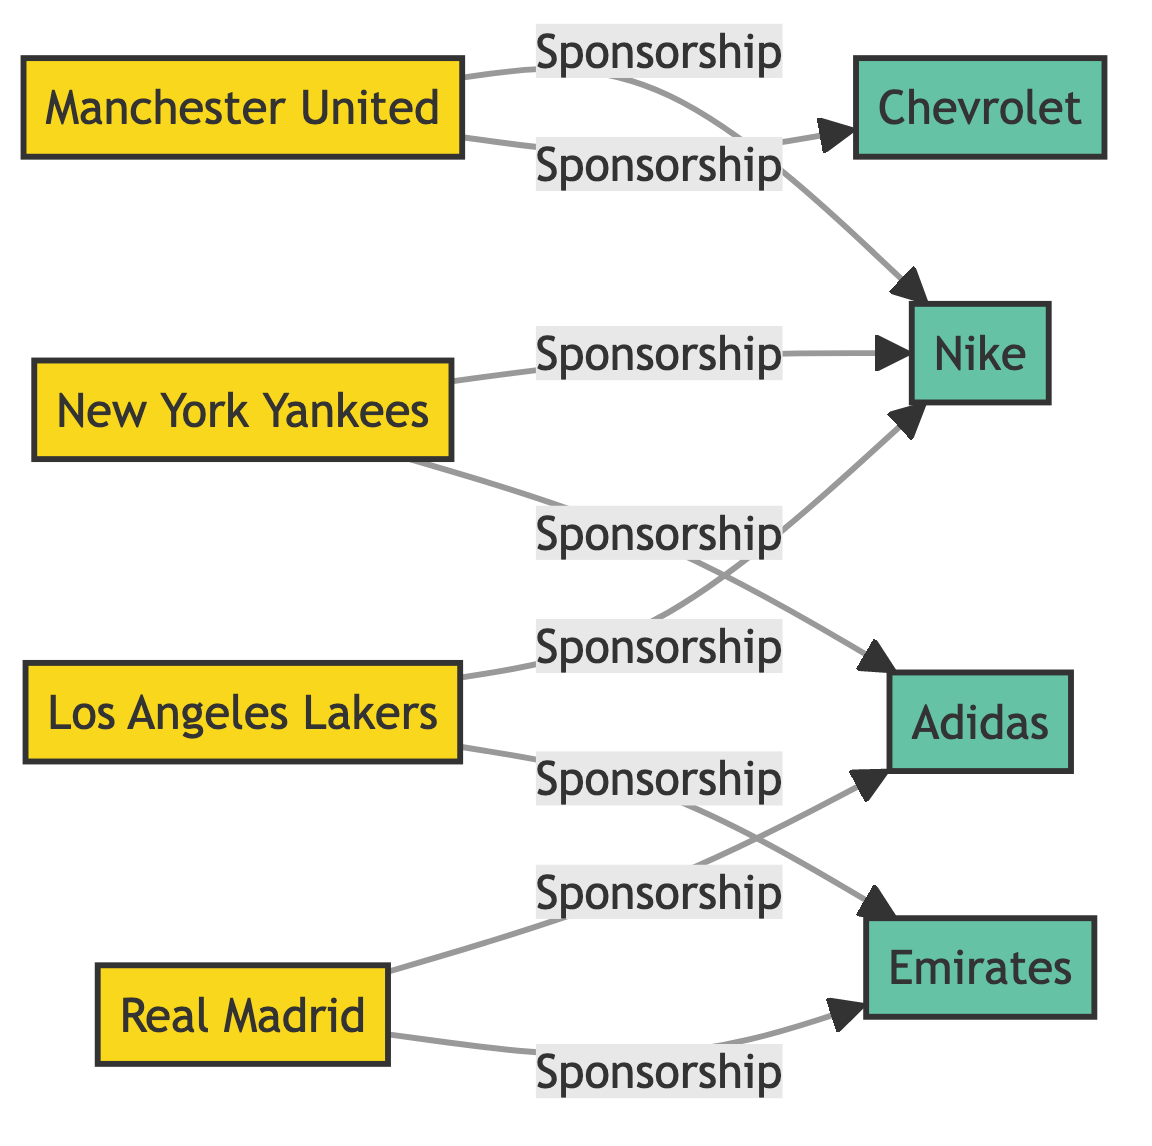What is the total number of teams in the network? The diagram lists four teams: Manchester United, Real Madrid, New York Yankees, and Los Angeles Lakers. By counting the nodes labeled as "Team," we find that there are a total of four teams.
Answer: 4 What sponsor is associated with Manchester United? The diagram shows two connections: Manchester United is connected to Nike and Chevrolet under the "Sponsorship" label. Thus, both of these sponsors are associated with Manchester United.
Answer: Nike and Chevrolet How many sponsorship connections does Real Madrid have? Real Madrid is connected to two sponsors: Adidas and Emirates. By counting the edges leading from Real Madrid to its sponsors, we determine that there are two sponsorship connections.
Answer: 2 Which team has the most sponsorship connections? Upon examining the connections, Manchester United, New York Yankees, and Los Angeles Lakers each have two sponsorships. Real Madrid has two as well. Thus, all teams mentioned have the same maximum number of sponsorship connections.
Answer: Manchester United, New York Yankees, and Los Angeles Lakers (all with 2 connections) What is the relationship between New York Yankees and Adidas? There is a direct connection labeled "Sponsorship" between New York Yankees and Adidas in the diagram, indicating that Adidas is a sponsor for the New York Yankees.
Answer: Sponsorship Which two sponsors are connected to Los Angeles Lakers? Looking at the diagram, Los Angeles Lakers is connected to Nike and Emirates as sponsors, under the "Sponsorship" label. By identifying the edges from the Lakers, we conclude that these two sponsors are linked.
Answer: Nike and Emirates What type of diagram is being presented? The diagram is a network diagram that showcases a network of sports teams and their sponsorship connections, illustrated through nodes and edges.
Answer: Network Diagram Which sponsor is uniquely linked to Real Madrid? Analyzing the connections in the diagram, Emirates is shown as the sponsor solely linked to Real Madrid, while other sponsors have connections with different teams.
Answer: Emirates 